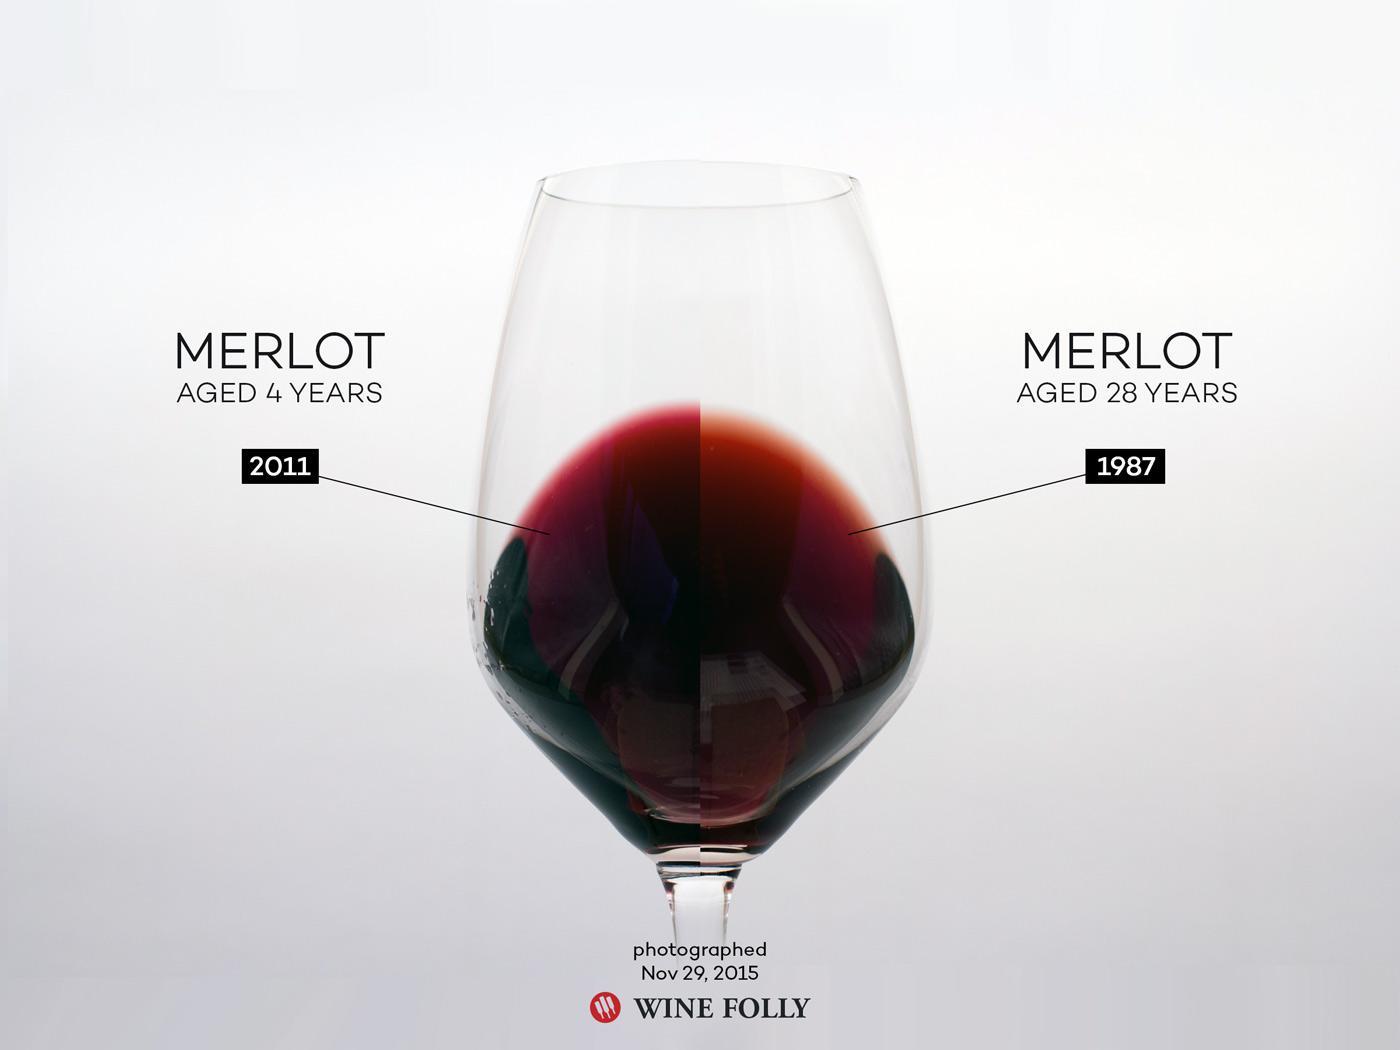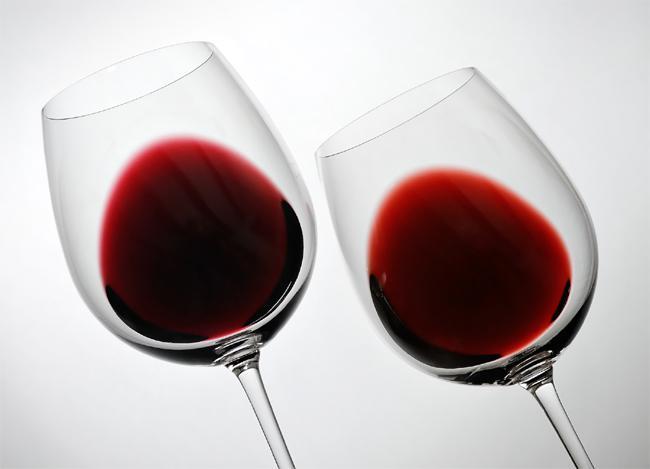The first image is the image on the left, the second image is the image on the right. For the images displayed, is the sentence "there are exactly two wine glasses in the image on the right." factually correct? Answer yes or no. Yes. 